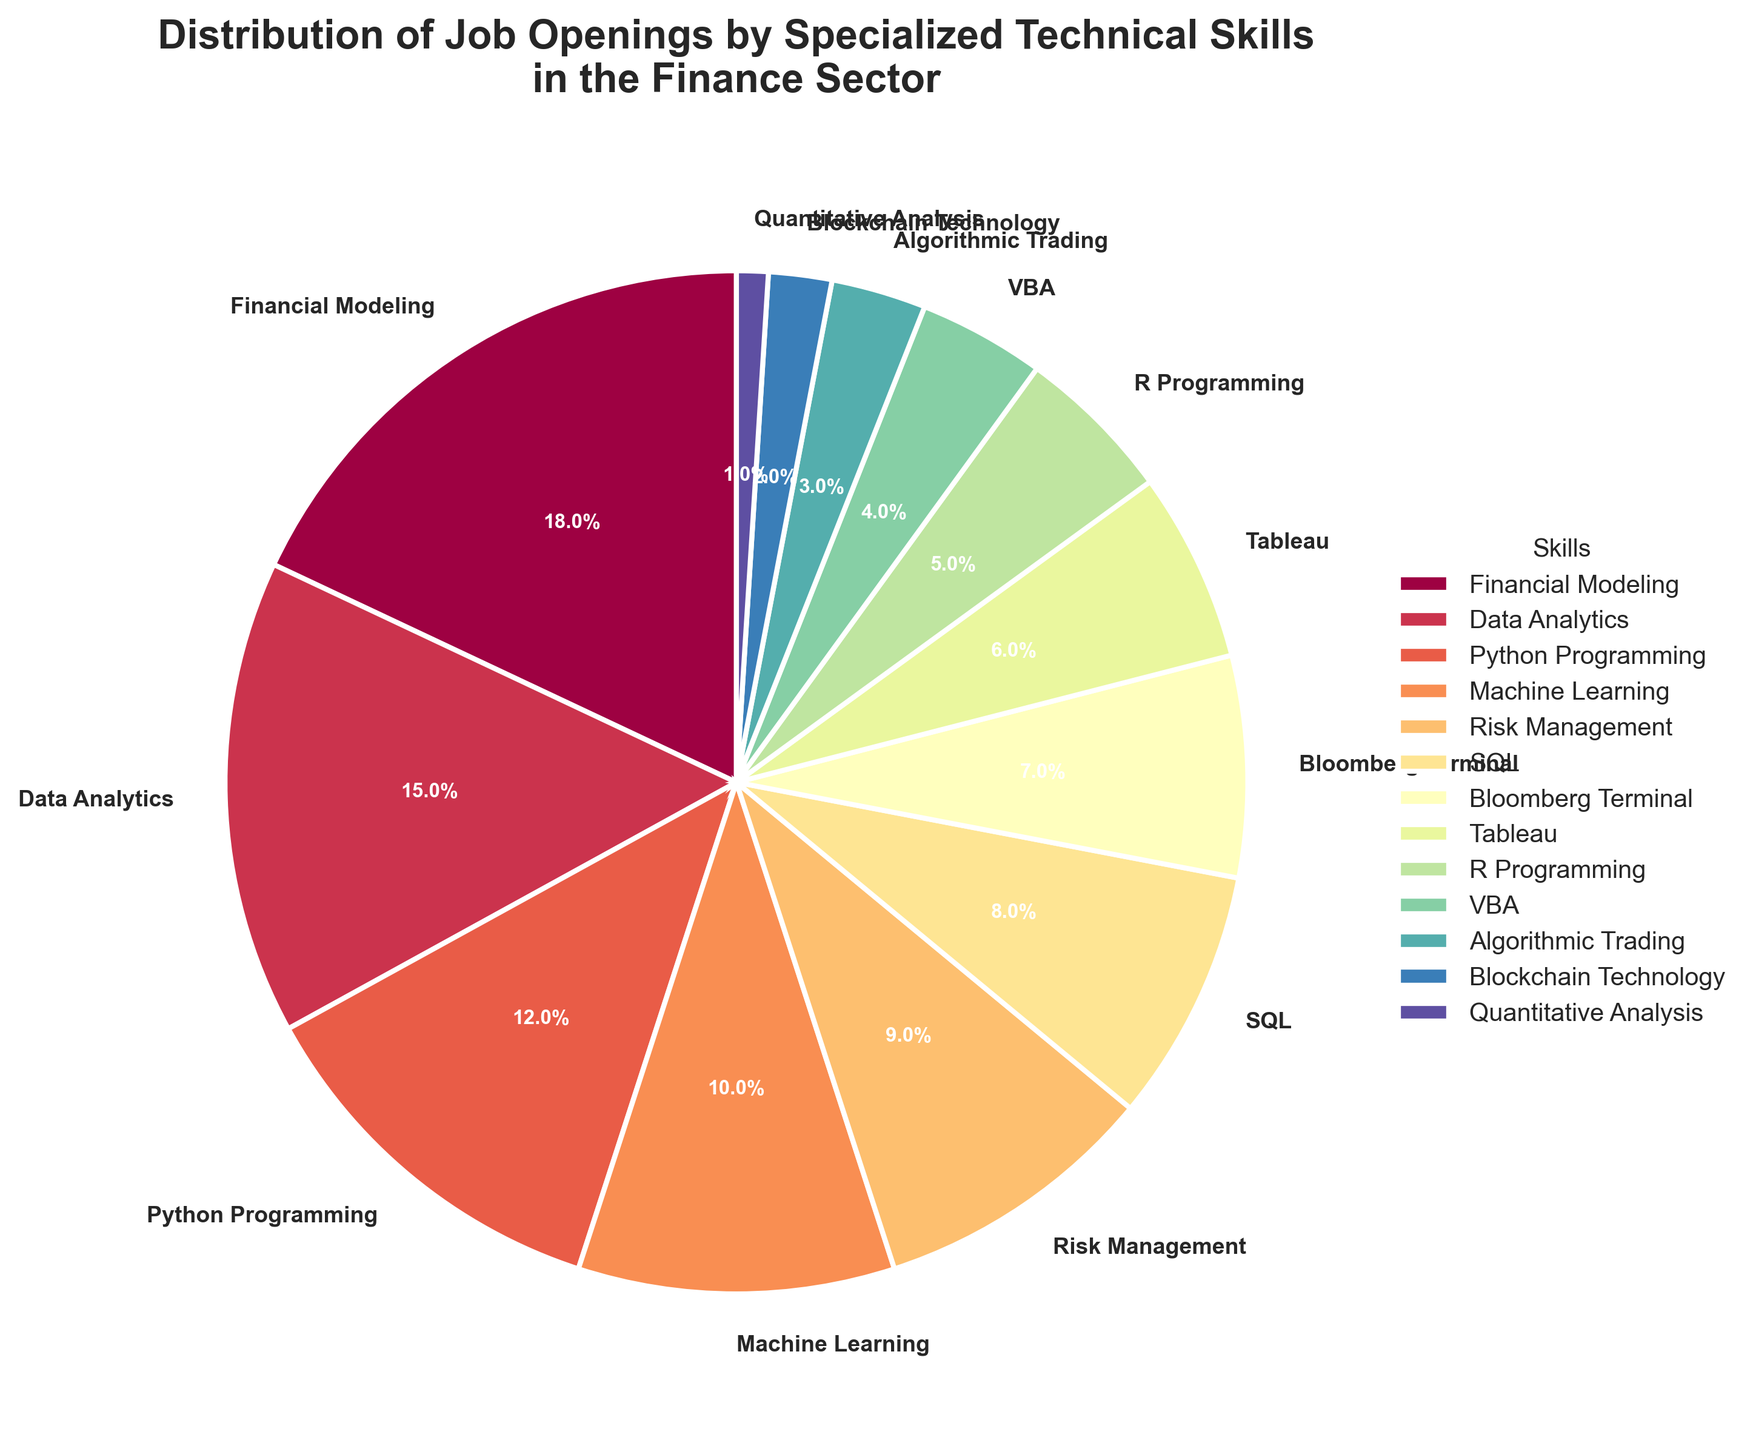Which skill has the highest percentage of job openings? The skill with the highest percentage of job openings is determined by looking at the largest slice in the pie chart. "Financial Modeling" appears to be the largest slice, which corresponds to the highest percentage.
Answer: Financial Modeling Compare the percentage of job openings requiring Python Programming and SQL. Which one is higher and by how much? To compare the two skills, locate the slices representing "Python Programming" and "SQL" in the pie chart. Python Programming is 12% and SQL is 8%. Subtract the percentage of SQL from Python Programming: 12% - 8% = 4%.
Answer: Python Programming is higher by 4% What's the combined percentage of job openings requiring Financial Modeling and Data Analytics? Sum the percentages of "Financial Modeling" (18%) and "Data Analytics" (15%). 18% + 15% = 33%.
Answer: 33% How does the combined percentage of job openings requiring Machine Learning and Risk Management compare to that for Python Programming? First, sum the percentages of "Machine Learning" (10%) and "Risk Management" (9%): 10% + 9% = 19%. Then, compare this value to "Python Programming" (12%). 19% > 12%.
Answer: Combined percentage for Machine Learning and Risk Management is higher Which skill has the smallest percentage of job openings? The smallest slice of the pie chart corresponds to the skill with the lowest percentage. "Quantitative Analysis," which is 1%.
Answer: Quantitative Analysis What's the difference between the highest and the lowest percentage of job openings by skill? Identify the highest percentage, which is "Financial Modeling" (18%), and the lowest percentage, which is "Quantitative Analysis" (1%). Subtract the lowest from the highest: 18% - 1% = 17%.
Answer: 17% What is the average percentage of job openings for SQL, VBA, and Algorithmic Trading? Calculate the average by summing the percentages for "SQL" (8%), "VBA" (4%), and "Algorithmic Trading" (3%) and then divide by the number of skills: (8% + 4% + 3%) / 3 = 5%.
Answer: 5% Which skills require greater than 10% of job openings? Look at the slices and identify those with percentages greater than 10%. These are "Financial Modeling" (18%), "Data Analytics" (15%), "Python Programming" (12%), and "Machine Learning" (10%).
Answer: Financial Modeling, Data Analytics, Python Programming, Machine Learning What is the cumulative percentage for job openings requiring Bloomberg Terminal, Tableau, and R Programming? Add the percentages of "Bloomberg Terminal" (7%), "Tableau" (6%), and "R Programming" (5%) together: 7% + 6% + 5% = 18%.
Answer: 18% What color represents the slice for Data Analytics? Identify the color of the slice labeled "Data Analytics" in the pie chart. This visual question depends on the color palette used, but based on the Spectral colormap, it might typically be vividly colored.
Answer: Varies by color palette (e.g., yellow/orange in many palettes) 